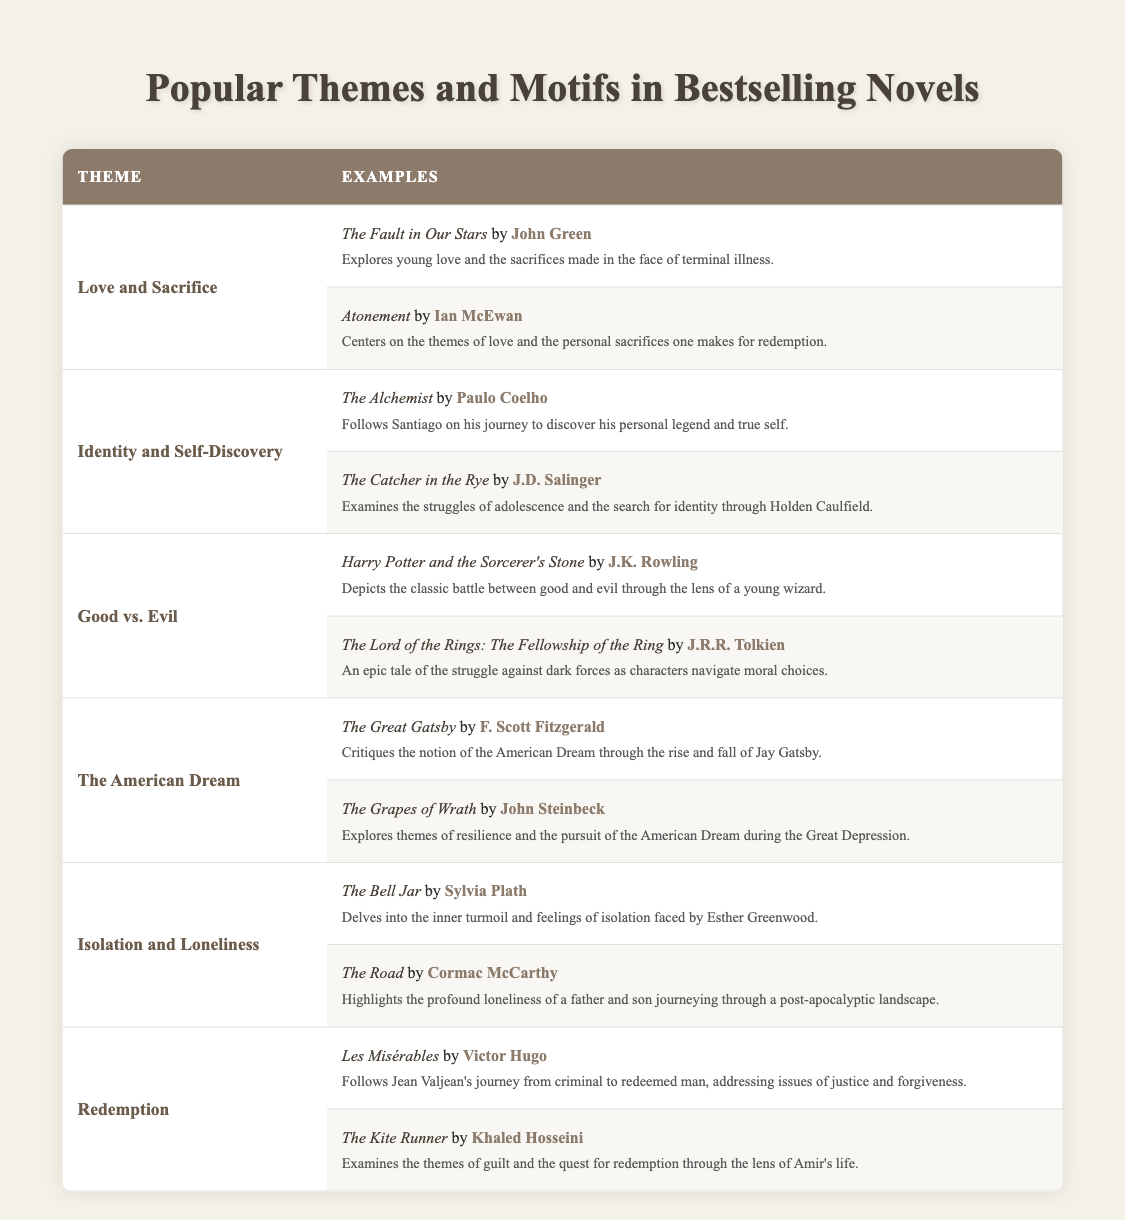What are some themes represented in bestselling novels? The table lists several themes, including Love and Sacrifice, Identity and Self-Discovery, Good vs. Evil, The American Dream, Isolation and Loneliness, and Redemption.
Answer: Love and Sacrifice, Identity and Self-Discovery, Good vs. Evil, The American Dream, Isolation and Loneliness, Redemption Which book by John Green is associated with the theme of Love and Sacrifice? According to the table, "The Fault in Our Stars" by John Green discusses the theme of Love and Sacrifice.
Answer: The Fault in Our Stars How many examples are given for the theme of Good vs. Evil? The table shows two examples under the theme of Good vs. Evil: "Harry Potter and the Sorcerer's Stone" and "The Lord of the Rings: The Fellowship of the Ring".
Answer: Two Is "Les Misérables" associated with the theme of Isolation and Loneliness? The table indicates that "Les Misérables" is categorized under the theme of Redemption, not Isolation and Loneliness.
Answer: No Which author addresses the theme of the American Dream? The authors who address the theme of the American Dream in the table are F. Scott Fitzgerald (in "The Great Gatsby") and John Steinbeck (in "The Grapes of Wrath").
Answer: F. Scott Fitzgerald, John Steinbeck Which book focuses on the journey of self-discovery? The table highlights "The Alchemist" by Paulo Coelho as one that focuses on self-discovery.
Answer: The Alchemist What is the common theme between "The Bell Jar" and "The Road"? Both books explore the theme of Isolation and Loneliness according to the table.
Answer: Isolation and Loneliness How many total themes are represented in this table? There are a total of six themes represented: Love and Sacrifice, Identity and Self-Discovery, Good vs. Evil, The American Dream, Isolation and Loneliness, and Redemption.
Answer: Six Which book is mentioned as examining guilt and the quest for redemption? According to the table, "The Kite Runner" by Khaled Hosseini examines guilt and the quest for redemption.
Answer: The Kite Runner Can you identify the two examples listed for the theme of Isolation and Loneliness? The two examples for the theme of Isolation and Loneliness are "The Bell Jar" by Sylvia Plath and "The Road" by Cormac McCarthy.
Answer: The Bell Jar, The Road What is the relationship between the themes of Love and Sacrifice and Redemption based on the examples provided? Both themes deal with deep personal experiences and transformations, as seen in "Atonement" (sacrifice for love) and "Les Misérables" (redemption journey), illustrating how sacrifice can lead to a quest for redemption.
Answer: Personal transformation through sacrifice 